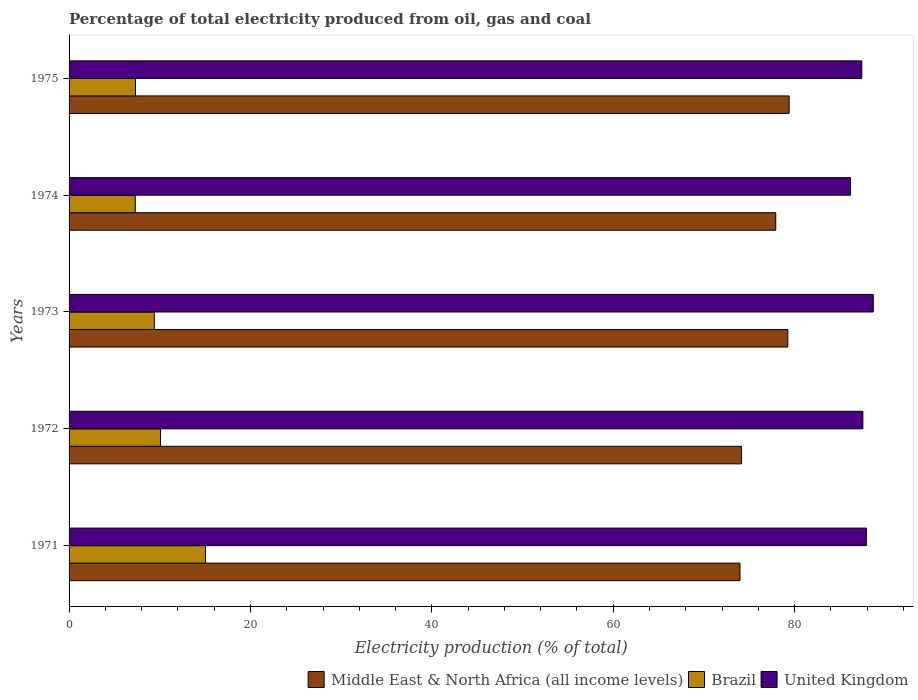How many different coloured bars are there?
Provide a short and direct response. 3. Are the number of bars on each tick of the Y-axis equal?
Give a very brief answer. Yes. How many bars are there on the 3rd tick from the top?
Your answer should be very brief. 3. What is the label of the 5th group of bars from the top?
Ensure brevity in your answer.  1971. In how many cases, is the number of bars for a given year not equal to the number of legend labels?
Provide a succinct answer. 0. What is the electricity production in in Brazil in 1972?
Provide a short and direct response. 10.08. Across all years, what is the maximum electricity production in in United Kingdom?
Provide a short and direct response. 88.68. Across all years, what is the minimum electricity production in in Middle East & North Africa (all income levels)?
Offer a very short reply. 73.98. In which year was the electricity production in in Brazil maximum?
Keep it short and to the point. 1971. In which year was the electricity production in in Middle East & North Africa (all income levels) minimum?
Your response must be concise. 1971. What is the total electricity production in in Brazil in the graph?
Give a very brief answer. 49.16. What is the difference between the electricity production in in Brazil in 1972 and that in 1974?
Offer a very short reply. 2.78. What is the difference between the electricity production in in Brazil in 1971 and the electricity production in in Middle East & North Africa (all income levels) in 1972?
Provide a succinct answer. -59.11. What is the average electricity production in in Brazil per year?
Offer a very short reply. 9.83. In the year 1971, what is the difference between the electricity production in in United Kingdom and electricity production in in Brazil?
Offer a very short reply. 72.87. What is the ratio of the electricity production in in Brazil in 1972 to that in 1973?
Your answer should be compact. 1.07. What is the difference between the highest and the second highest electricity production in in United Kingdom?
Offer a terse response. 0.76. What is the difference between the highest and the lowest electricity production in in Middle East & North Africa (all income levels)?
Your answer should be very brief. 5.42. Is the sum of the electricity production in in United Kingdom in 1972 and 1975 greater than the maximum electricity production in in Middle East & North Africa (all income levels) across all years?
Your answer should be very brief. Yes. How many bars are there?
Provide a succinct answer. 15. Are all the bars in the graph horizontal?
Keep it short and to the point. Yes. How many years are there in the graph?
Provide a succinct answer. 5. Are the values on the major ticks of X-axis written in scientific E-notation?
Ensure brevity in your answer.  No. Does the graph contain any zero values?
Keep it short and to the point. No. Does the graph contain grids?
Provide a short and direct response. No. How are the legend labels stacked?
Make the answer very short. Horizontal. What is the title of the graph?
Keep it short and to the point. Percentage of total electricity produced from oil, gas and coal. What is the label or title of the X-axis?
Provide a succinct answer. Electricity production (% of total). What is the Electricity production (% of total) of Middle East & North Africa (all income levels) in 1971?
Your response must be concise. 73.98. What is the Electricity production (% of total) of Brazil in 1971?
Offer a terse response. 15.05. What is the Electricity production (% of total) in United Kingdom in 1971?
Offer a very short reply. 87.92. What is the Electricity production (% of total) in Middle East & North Africa (all income levels) in 1972?
Give a very brief answer. 74.16. What is the Electricity production (% of total) of Brazil in 1972?
Your response must be concise. 10.08. What is the Electricity production (% of total) of United Kingdom in 1972?
Ensure brevity in your answer.  87.53. What is the Electricity production (% of total) in Middle East & North Africa (all income levels) in 1973?
Offer a very short reply. 79.25. What is the Electricity production (% of total) of Brazil in 1973?
Provide a short and direct response. 9.4. What is the Electricity production (% of total) in United Kingdom in 1973?
Provide a short and direct response. 88.68. What is the Electricity production (% of total) in Middle East & North Africa (all income levels) in 1974?
Keep it short and to the point. 77.92. What is the Electricity production (% of total) of Brazil in 1974?
Provide a short and direct response. 7.3. What is the Electricity production (% of total) of United Kingdom in 1974?
Provide a short and direct response. 86.17. What is the Electricity production (% of total) of Middle East & North Africa (all income levels) in 1975?
Provide a succinct answer. 79.4. What is the Electricity production (% of total) of Brazil in 1975?
Your answer should be compact. 7.33. What is the Electricity production (% of total) in United Kingdom in 1975?
Offer a very short reply. 87.41. Across all years, what is the maximum Electricity production (% of total) in Middle East & North Africa (all income levels)?
Provide a short and direct response. 79.4. Across all years, what is the maximum Electricity production (% of total) of Brazil?
Provide a short and direct response. 15.05. Across all years, what is the maximum Electricity production (% of total) of United Kingdom?
Ensure brevity in your answer.  88.68. Across all years, what is the minimum Electricity production (% of total) in Middle East & North Africa (all income levels)?
Your response must be concise. 73.98. Across all years, what is the minimum Electricity production (% of total) in Brazil?
Provide a short and direct response. 7.3. Across all years, what is the minimum Electricity production (% of total) of United Kingdom?
Your response must be concise. 86.17. What is the total Electricity production (% of total) of Middle East & North Africa (all income levels) in the graph?
Make the answer very short. 384.71. What is the total Electricity production (% of total) in Brazil in the graph?
Your answer should be very brief. 49.16. What is the total Electricity production (% of total) of United Kingdom in the graph?
Make the answer very short. 437.7. What is the difference between the Electricity production (% of total) of Middle East & North Africa (all income levels) in 1971 and that in 1972?
Your response must be concise. -0.18. What is the difference between the Electricity production (% of total) of Brazil in 1971 and that in 1972?
Offer a terse response. 4.96. What is the difference between the Electricity production (% of total) in United Kingdom in 1971 and that in 1972?
Offer a terse response. 0.39. What is the difference between the Electricity production (% of total) in Middle East & North Africa (all income levels) in 1971 and that in 1973?
Provide a succinct answer. -5.27. What is the difference between the Electricity production (% of total) of Brazil in 1971 and that in 1973?
Your answer should be compact. 5.64. What is the difference between the Electricity production (% of total) of United Kingdom in 1971 and that in 1973?
Keep it short and to the point. -0.76. What is the difference between the Electricity production (% of total) in Middle East & North Africa (all income levels) in 1971 and that in 1974?
Provide a short and direct response. -3.94. What is the difference between the Electricity production (% of total) in Brazil in 1971 and that in 1974?
Give a very brief answer. 7.75. What is the difference between the Electricity production (% of total) in United Kingdom in 1971 and that in 1974?
Provide a short and direct response. 1.75. What is the difference between the Electricity production (% of total) of Middle East & North Africa (all income levels) in 1971 and that in 1975?
Your answer should be very brief. -5.42. What is the difference between the Electricity production (% of total) of Brazil in 1971 and that in 1975?
Offer a terse response. 7.72. What is the difference between the Electricity production (% of total) in United Kingdom in 1971 and that in 1975?
Your response must be concise. 0.5. What is the difference between the Electricity production (% of total) in Middle East & North Africa (all income levels) in 1972 and that in 1973?
Your answer should be compact. -5.1. What is the difference between the Electricity production (% of total) in Brazil in 1972 and that in 1973?
Keep it short and to the point. 0.68. What is the difference between the Electricity production (% of total) in United Kingdom in 1972 and that in 1973?
Keep it short and to the point. -1.15. What is the difference between the Electricity production (% of total) of Middle East & North Africa (all income levels) in 1972 and that in 1974?
Give a very brief answer. -3.77. What is the difference between the Electricity production (% of total) of Brazil in 1972 and that in 1974?
Give a very brief answer. 2.78. What is the difference between the Electricity production (% of total) in United Kingdom in 1972 and that in 1974?
Keep it short and to the point. 1.36. What is the difference between the Electricity production (% of total) of Middle East & North Africa (all income levels) in 1972 and that in 1975?
Provide a succinct answer. -5.24. What is the difference between the Electricity production (% of total) in Brazil in 1972 and that in 1975?
Keep it short and to the point. 2.76. What is the difference between the Electricity production (% of total) of United Kingdom in 1972 and that in 1975?
Your answer should be very brief. 0.12. What is the difference between the Electricity production (% of total) in Middle East & North Africa (all income levels) in 1973 and that in 1974?
Ensure brevity in your answer.  1.33. What is the difference between the Electricity production (% of total) of Brazil in 1973 and that in 1974?
Give a very brief answer. 2.1. What is the difference between the Electricity production (% of total) of United Kingdom in 1973 and that in 1974?
Provide a short and direct response. 2.51. What is the difference between the Electricity production (% of total) in Middle East & North Africa (all income levels) in 1973 and that in 1975?
Provide a short and direct response. -0.15. What is the difference between the Electricity production (% of total) of Brazil in 1973 and that in 1975?
Your answer should be compact. 2.08. What is the difference between the Electricity production (% of total) in United Kingdom in 1973 and that in 1975?
Provide a short and direct response. 1.27. What is the difference between the Electricity production (% of total) in Middle East & North Africa (all income levels) in 1974 and that in 1975?
Your answer should be compact. -1.47. What is the difference between the Electricity production (% of total) in Brazil in 1974 and that in 1975?
Provide a short and direct response. -0.02. What is the difference between the Electricity production (% of total) of United Kingdom in 1974 and that in 1975?
Your answer should be very brief. -1.24. What is the difference between the Electricity production (% of total) in Middle East & North Africa (all income levels) in 1971 and the Electricity production (% of total) in Brazil in 1972?
Your response must be concise. 63.9. What is the difference between the Electricity production (% of total) of Middle East & North Africa (all income levels) in 1971 and the Electricity production (% of total) of United Kingdom in 1972?
Offer a very short reply. -13.55. What is the difference between the Electricity production (% of total) of Brazil in 1971 and the Electricity production (% of total) of United Kingdom in 1972?
Keep it short and to the point. -72.48. What is the difference between the Electricity production (% of total) of Middle East & North Africa (all income levels) in 1971 and the Electricity production (% of total) of Brazil in 1973?
Offer a very short reply. 64.58. What is the difference between the Electricity production (% of total) of Middle East & North Africa (all income levels) in 1971 and the Electricity production (% of total) of United Kingdom in 1973?
Your response must be concise. -14.7. What is the difference between the Electricity production (% of total) in Brazil in 1971 and the Electricity production (% of total) in United Kingdom in 1973?
Your answer should be compact. -73.63. What is the difference between the Electricity production (% of total) of Middle East & North Africa (all income levels) in 1971 and the Electricity production (% of total) of Brazil in 1974?
Make the answer very short. 66.68. What is the difference between the Electricity production (% of total) of Middle East & North Africa (all income levels) in 1971 and the Electricity production (% of total) of United Kingdom in 1974?
Ensure brevity in your answer.  -12.19. What is the difference between the Electricity production (% of total) in Brazil in 1971 and the Electricity production (% of total) in United Kingdom in 1974?
Keep it short and to the point. -71.12. What is the difference between the Electricity production (% of total) in Middle East & North Africa (all income levels) in 1971 and the Electricity production (% of total) in Brazil in 1975?
Your answer should be very brief. 66.65. What is the difference between the Electricity production (% of total) in Middle East & North Africa (all income levels) in 1971 and the Electricity production (% of total) in United Kingdom in 1975?
Provide a short and direct response. -13.43. What is the difference between the Electricity production (% of total) in Brazil in 1971 and the Electricity production (% of total) in United Kingdom in 1975?
Make the answer very short. -72.36. What is the difference between the Electricity production (% of total) of Middle East & North Africa (all income levels) in 1972 and the Electricity production (% of total) of Brazil in 1973?
Provide a succinct answer. 64.75. What is the difference between the Electricity production (% of total) in Middle East & North Africa (all income levels) in 1972 and the Electricity production (% of total) in United Kingdom in 1973?
Your answer should be compact. -14.52. What is the difference between the Electricity production (% of total) of Brazil in 1972 and the Electricity production (% of total) of United Kingdom in 1973?
Offer a terse response. -78.59. What is the difference between the Electricity production (% of total) of Middle East & North Africa (all income levels) in 1972 and the Electricity production (% of total) of Brazil in 1974?
Your response must be concise. 66.85. What is the difference between the Electricity production (% of total) of Middle East & North Africa (all income levels) in 1972 and the Electricity production (% of total) of United Kingdom in 1974?
Provide a short and direct response. -12.01. What is the difference between the Electricity production (% of total) in Brazil in 1972 and the Electricity production (% of total) in United Kingdom in 1974?
Offer a very short reply. -76.08. What is the difference between the Electricity production (% of total) of Middle East & North Africa (all income levels) in 1972 and the Electricity production (% of total) of Brazil in 1975?
Your response must be concise. 66.83. What is the difference between the Electricity production (% of total) of Middle East & North Africa (all income levels) in 1972 and the Electricity production (% of total) of United Kingdom in 1975?
Your answer should be very brief. -13.26. What is the difference between the Electricity production (% of total) in Brazil in 1972 and the Electricity production (% of total) in United Kingdom in 1975?
Provide a succinct answer. -77.33. What is the difference between the Electricity production (% of total) of Middle East & North Africa (all income levels) in 1973 and the Electricity production (% of total) of Brazil in 1974?
Provide a succinct answer. 71.95. What is the difference between the Electricity production (% of total) of Middle East & North Africa (all income levels) in 1973 and the Electricity production (% of total) of United Kingdom in 1974?
Keep it short and to the point. -6.91. What is the difference between the Electricity production (% of total) of Brazil in 1973 and the Electricity production (% of total) of United Kingdom in 1974?
Provide a succinct answer. -76.76. What is the difference between the Electricity production (% of total) in Middle East & North Africa (all income levels) in 1973 and the Electricity production (% of total) in Brazil in 1975?
Give a very brief answer. 71.93. What is the difference between the Electricity production (% of total) of Middle East & North Africa (all income levels) in 1973 and the Electricity production (% of total) of United Kingdom in 1975?
Provide a succinct answer. -8.16. What is the difference between the Electricity production (% of total) in Brazil in 1973 and the Electricity production (% of total) in United Kingdom in 1975?
Provide a short and direct response. -78.01. What is the difference between the Electricity production (% of total) of Middle East & North Africa (all income levels) in 1974 and the Electricity production (% of total) of Brazil in 1975?
Provide a short and direct response. 70.6. What is the difference between the Electricity production (% of total) in Middle East & North Africa (all income levels) in 1974 and the Electricity production (% of total) in United Kingdom in 1975?
Offer a very short reply. -9.49. What is the difference between the Electricity production (% of total) in Brazil in 1974 and the Electricity production (% of total) in United Kingdom in 1975?
Make the answer very short. -80.11. What is the average Electricity production (% of total) of Middle East & North Africa (all income levels) per year?
Your response must be concise. 76.94. What is the average Electricity production (% of total) in Brazil per year?
Make the answer very short. 9.83. What is the average Electricity production (% of total) of United Kingdom per year?
Your answer should be compact. 87.54. In the year 1971, what is the difference between the Electricity production (% of total) in Middle East & North Africa (all income levels) and Electricity production (% of total) in Brazil?
Give a very brief answer. 58.93. In the year 1971, what is the difference between the Electricity production (% of total) of Middle East & North Africa (all income levels) and Electricity production (% of total) of United Kingdom?
Keep it short and to the point. -13.94. In the year 1971, what is the difference between the Electricity production (% of total) in Brazil and Electricity production (% of total) in United Kingdom?
Your answer should be compact. -72.87. In the year 1972, what is the difference between the Electricity production (% of total) of Middle East & North Africa (all income levels) and Electricity production (% of total) of Brazil?
Make the answer very short. 64.07. In the year 1972, what is the difference between the Electricity production (% of total) of Middle East & North Africa (all income levels) and Electricity production (% of total) of United Kingdom?
Offer a very short reply. -13.37. In the year 1972, what is the difference between the Electricity production (% of total) of Brazil and Electricity production (% of total) of United Kingdom?
Keep it short and to the point. -77.44. In the year 1973, what is the difference between the Electricity production (% of total) in Middle East & North Africa (all income levels) and Electricity production (% of total) in Brazil?
Your answer should be compact. 69.85. In the year 1973, what is the difference between the Electricity production (% of total) of Middle East & North Africa (all income levels) and Electricity production (% of total) of United Kingdom?
Keep it short and to the point. -9.43. In the year 1973, what is the difference between the Electricity production (% of total) in Brazil and Electricity production (% of total) in United Kingdom?
Your response must be concise. -79.28. In the year 1974, what is the difference between the Electricity production (% of total) of Middle East & North Africa (all income levels) and Electricity production (% of total) of Brazil?
Your answer should be compact. 70.62. In the year 1974, what is the difference between the Electricity production (% of total) in Middle East & North Africa (all income levels) and Electricity production (% of total) in United Kingdom?
Offer a terse response. -8.24. In the year 1974, what is the difference between the Electricity production (% of total) of Brazil and Electricity production (% of total) of United Kingdom?
Your response must be concise. -78.86. In the year 1975, what is the difference between the Electricity production (% of total) in Middle East & North Africa (all income levels) and Electricity production (% of total) in Brazil?
Offer a terse response. 72.07. In the year 1975, what is the difference between the Electricity production (% of total) of Middle East & North Africa (all income levels) and Electricity production (% of total) of United Kingdom?
Offer a terse response. -8.01. In the year 1975, what is the difference between the Electricity production (% of total) of Brazil and Electricity production (% of total) of United Kingdom?
Give a very brief answer. -80.09. What is the ratio of the Electricity production (% of total) of Brazil in 1971 to that in 1972?
Offer a terse response. 1.49. What is the ratio of the Electricity production (% of total) in United Kingdom in 1971 to that in 1972?
Provide a short and direct response. 1. What is the ratio of the Electricity production (% of total) of Middle East & North Africa (all income levels) in 1971 to that in 1973?
Give a very brief answer. 0.93. What is the ratio of the Electricity production (% of total) in Brazil in 1971 to that in 1973?
Make the answer very short. 1.6. What is the ratio of the Electricity production (% of total) of United Kingdom in 1971 to that in 1973?
Ensure brevity in your answer.  0.99. What is the ratio of the Electricity production (% of total) in Middle East & North Africa (all income levels) in 1971 to that in 1974?
Offer a very short reply. 0.95. What is the ratio of the Electricity production (% of total) in Brazil in 1971 to that in 1974?
Keep it short and to the point. 2.06. What is the ratio of the Electricity production (% of total) of United Kingdom in 1971 to that in 1974?
Your response must be concise. 1.02. What is the ratio of the Electricity production (% of total) in Middle East & North Africa (all income levels) in 1971 to that in 1975?
Provide a short and direct response. 0.93. What is the ratio of the Electricity production (% of total) of Brazil in 1971 to that in 1975?
Offer a terse response. 2.05. What is the ratio of the Electricity production (% of total) of Middle East & North Africa (all income levels) in 1972 to that in 1973?
Make the answer very short. 0.94. What is the ratio of the Electricity production (% of total) in Brazil in 1972 to that in 1973?
Provide a succinct answer. 1.07. What is the ratio of the Electricity production (% of total) of Middle East & North Africa (all income levels) in 1972 to that in 1974?
Offer a very short reply. 0.95. What is the ratio of the Electricity production (% of total) of Brazil in 1972 to that in 1974?
Your response must be concise. 1.38. What is the ratio of the Electricity production (% of total) of United Kingdom in 1972 to that in 1974?
Keep it short and to the point. 1.02. What is the ratio of the Electricity production (% of total) in Middle East & North Africa (all income levels) in 1972 to that in 1975?
Provide a short and direct response. 0.93. What is the ratio of the Electricity production (% of total) of Brazil in 1972 to that in 1975?
Make the answer very short. 1.38. What is the ratio of the Electricity production (% of total) of United Kingdom in 1972 to that in 1975?
Provide a short and direct response. 1. What is the ratio of the Electricity production (% of total) in Middle East & North Africa (all income levels) in 1973 to that in 1974?
Your answer should be compact. 1.02. What is the ratio of the Electricity production (% of total) in Brazil in 1973 to that in 1974?
Offer a very short reply. 1.29. What is the ratio of the Electricity production (% of total) of United Kingdom in 1973 to that in 1974?
Your answer should be very brief. 1.03. What is the ratio of the Electricity production (% of total) of Middle East & North Africa (all income levels) in 1973 to that in 1975?
Your answer should be compact. 1. What is the ratio of the Electricity production (% of total) of Brazil in 1973 to that in 1975?
Offer a very short reply. 1.28. What is the ratio of the Electricity production (% of total) in United Kingdom in 1973 to that in 1975?
Your response must be concise. 1.01. What is the ratio of the Electricity production (% of total) of Middle East & North Africa (all income levels) in 1974 to that in 1975?
Your answer should be very brief. 0.98. What is the ratio of the Electricity production (% of total) in United Kingdom in 1974 to that in 1975?
Keep it short and to the point. 0.99. What is the difference between the highest and the second highest Electricity production (% of total) in Middle East & North Africa (all income levels)?
Offer a very short reply. 0.15. What is the difference between the highest and the second highest Electricity production (% of total) of Brazil?
Keep it short and to the point. 4.96. What is the difference between the highest and the second highest Electricity production (% of total) in United Kingdom?
Provide a short and direct response. 0.76. What is the difference between the highest and the lowest Electricity production (% of total) of Middle East & North Africa (all income levels)?
Keep it short and to the point. 5.42. What is the difference between the highest and the lowest Electricity production (% of total) of Brazil?
Keep it short and to the point. 7.75. What is the difference between the highest and the lowest Electricity production (% of total) of United Kingdom?
Give a very brief answer. 2.51. 